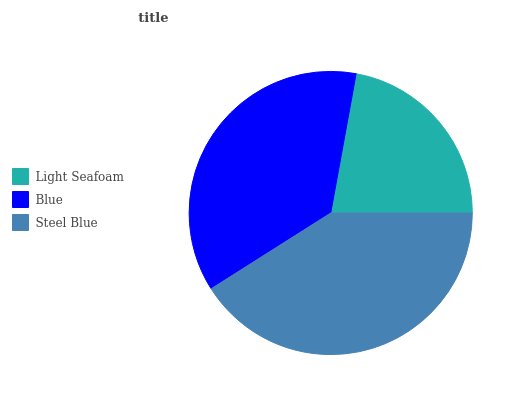Is Light Seafoam the minimum?
Answer yes or no. Yes. Is Steel Blue the maximum?
Answer yes or no. Yes. Is Blue the minimum?
Answer yes or no. No. Is Blue the maximum?
Answer yes or no. No. Is Blue greater than Light Seafoam?
Answer yes or no. Yes. Is Light Seafoam less than Blue?
Answer yes or no. Yes. Is Light Seafoam greater than Blue?
Answer yes or no. No. Is Blue less than Light Seafoam?
Answer yes or no. No. Is Blue the high median?
Answer yes or no. Yes. Is Blue the low median?
Answer yes or no. Yes. Is Light Seafoam the high median?
Answer yes or no. No. Is Light Seafoam the low median?
Answer yes or no. No. 